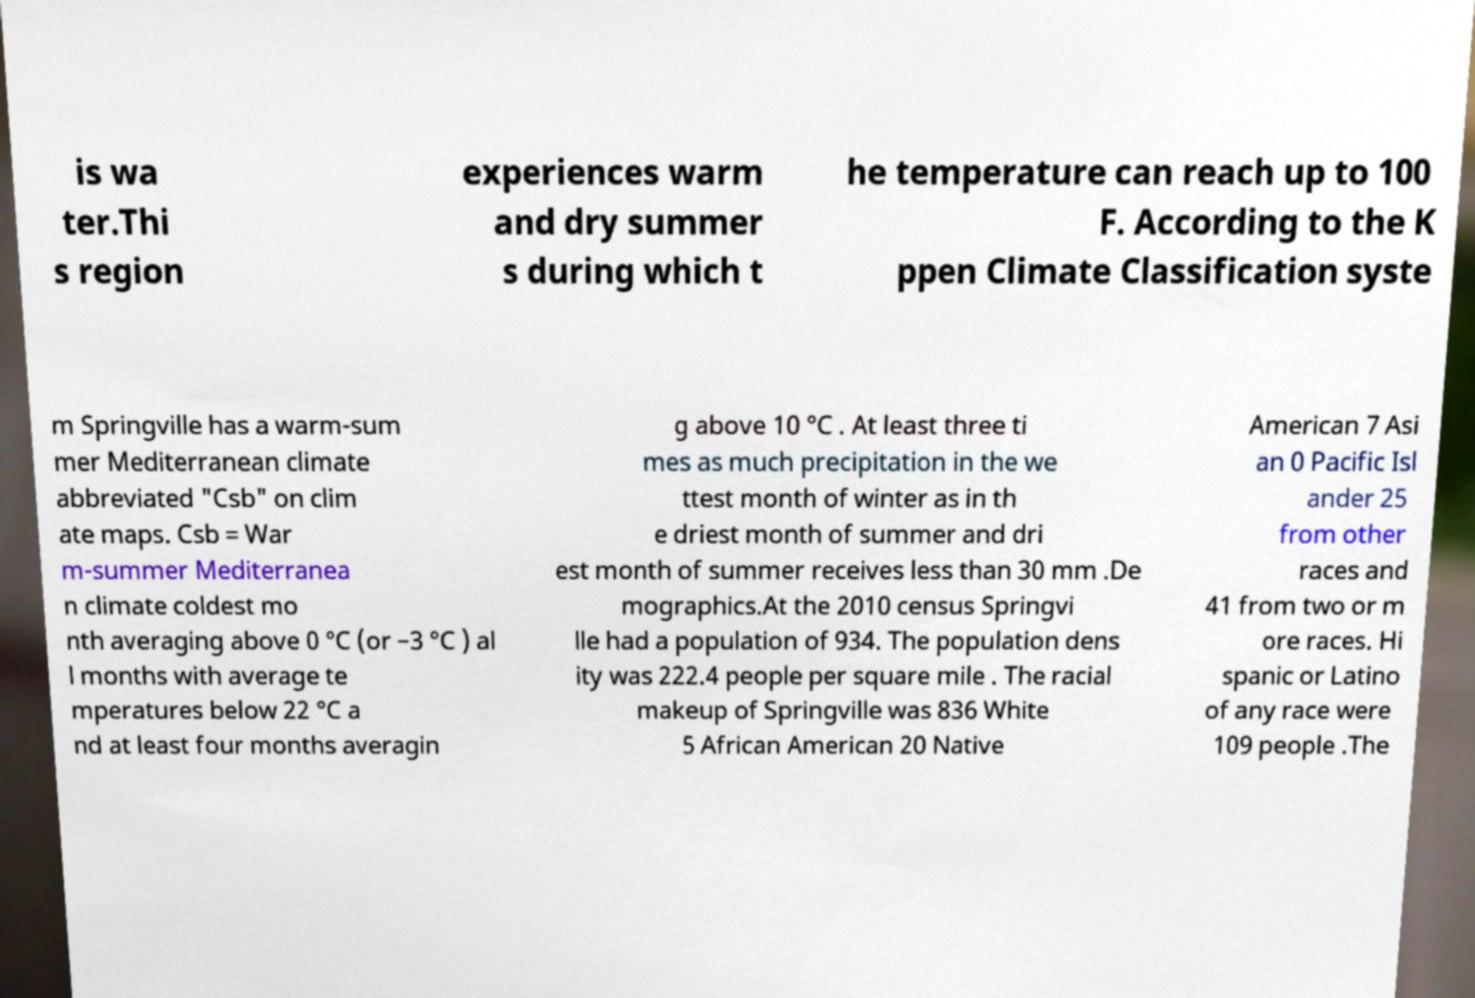I need the written content from this picture converted into text. Can you do that? is wa ter.Thi s region experiences warm and dry summer s during which t he temperature can reach up to 100 F. According to the K ppen Climate Classification syste m Springville has a warm-sum mer Mediterranean climate abbreviated "Csb" on clim ate maps. Csb = War m-summer Mediterranea n climate coldest mo nth averaging above 0 °C (or −3 °C ) al l months with average te mperatures below 22 °C a nd at least four months averagin g above 10 °C . At least three ti mes as much precipitation in the we ttest month of winter as in th e driest month of summer and dri est month of summer receives less than 30 mm .De mographics.At the 2010 census Springvi lle had a population of 934. The population dens ity was 222.4 people per square mile . The racial makeup of Springville was 836 White 5 African American 20 Native American 7 Asi an 0 Pacific Isl ander 25 from other races and 41 from two or m ore races. Hi spanic or Latino of any race were 109 people .The 